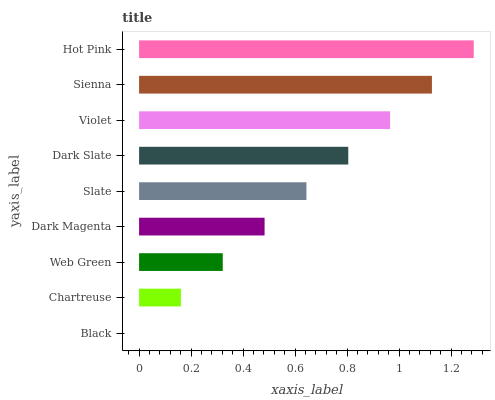Is Black the minimum?
Answer yes or no. Yes. Is Hot Pink the maximum?
Answer yes or no. Yes. Is Chartreuse the minimum?
Answer yes or no. No. Is Chartreuse the maximum?
Answer yes or no. No. Is Chartreuse greater than Black?
Answer yes or no. Yes. Is Black less than Chartreuse?
Answer yes or no. Yes. Is Black greater than Chartreuse?
Answer yes or no. No. Is Chartreuse less than Black?
Answer yes or no. No. Is Slate the high median?
Answer yes or no. Yes. Is Slate the low median?
Answer yes or no. Yes. Is Dark Magenta the high median?
Answer yes or no. No. Is Sienna the low median?
Answer yes or no. No. 